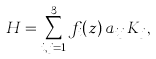<formula> <loc_0><loc_0><loc_500><loc_500>H = \sum _ { i , j = 1 } ^ { 3 } f _ { i } ( z ) \, a _ { i j } \, K _ { j } ,</formula> 